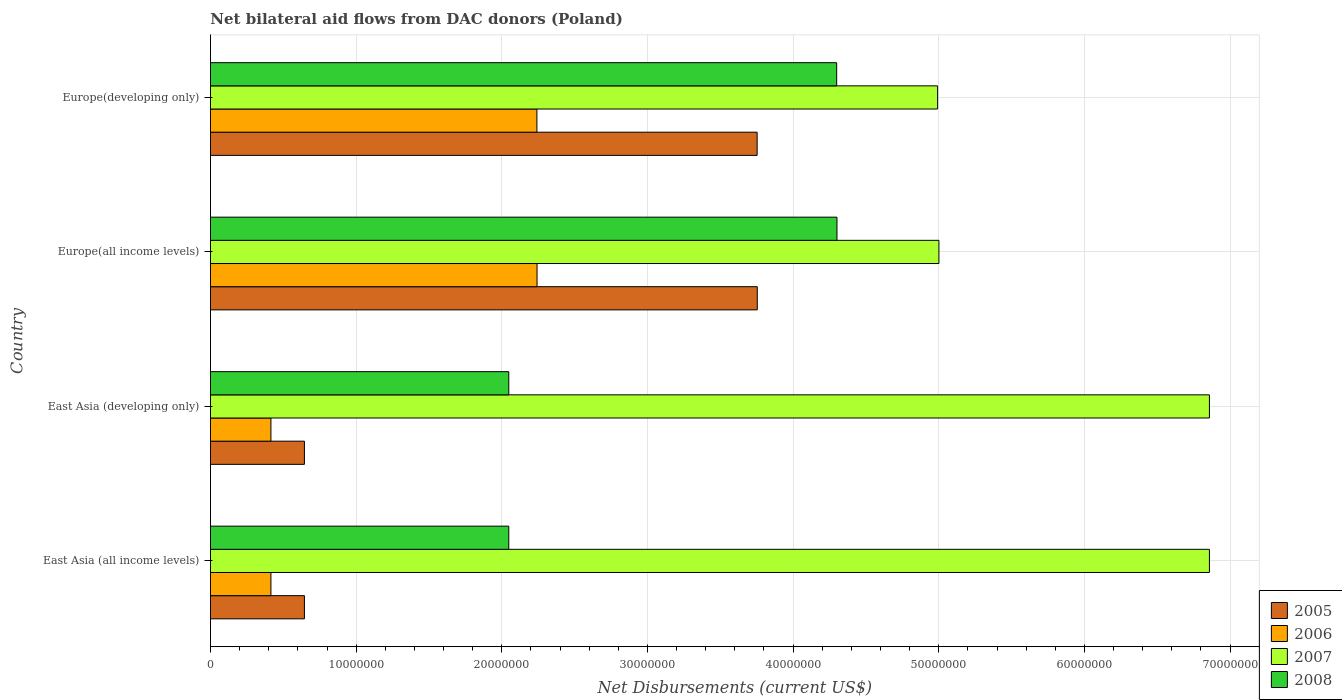Are the number of bars per tick equal to the number of legend labels?
Your answer should be very brief. Yes. How many bars are there on the 4th tick from the top?
Make the answer very short. 4. What is the label of the 2nd group of bars from the top?
Offer a very short reply. Europe(all income levels). In how many cases, is the number of bars for a given country not equal to the number of legend labels?
Ensure brevity in your answer.  0. What is the net bilateral aid flows in 2005 in East Asia (developing only)?
Give a very brief answer. 6.45e+06. Across all countries, what is the maximum net bilateral aid flows in 2007?
Ensure brevity in your answer.  6.86e+07. Across all countries, what is the minimum net bilateral aid flows in 2005?
Give a very brief answer. 6.45e+06. In which country was the net bilateral aid flows in 2006 maximum?
Your answer should be compact. Europe(all income levels). In which country was the net bilateral aid flows in 2006 minimum?
Ensure brevity in your answer.  East Asia (all income levels). What is the total net bilateral aid flows in 2007 in the graph?
Your answer should be compact. 2.37e+08. What is the difference between the net bilateral aid flows in 2008 in East Asia (developing only) and that in Europe(developing only)?
Your answer should be very brief. -2.25e+07. What is the difference between the net bilateral aid flows in 2005 in Europe(developing only) and the net bilateral aid flows in 2006 in Europe(all income levels)?
Make the answer very short. 1.51e+07. What is the average net bilateral aid flows in 2007 per country?
Your response must be concise. 5.93e+07. What is the difference between the net bilateral aid flows in 2006 and net bilateral aid flows in 2008 in East Asia (developing only)?
Provide a short and direct response. -1.63e+07. What is the ratio of the net bilateral aid flows in 2006 in East Asia (all income levels) to that in Europe(developing only)?
Offer a very short reply. 0.19. Is the net bilateral aid flows in 2005 in East Asia (all income levels) less than that in Europe(developing only)?
Offer a terse response. Yes. Is the difference between the net bilateral aid flows in 2006 in East Asia (developing only) and Europe(developing only) greater than the difference between the net bilateral aid flows in 2008 in East Asia (developing only) and Europe(developing only)?
Make the answer very short. Yes. What is the difference between the highest and the lowest net bilateral aid flows in 2005?
Make the answer very short. 3.11e+07. In how many countries, is the net bilateral aid flows in 2006 greater than the average net bilateral aid flows in 2006 taken over all countries?
Make the answer very short. 2. Is the sum of the net bilateral aid flows in 2006 in East Asia (developing only) and Europe(all income levels) greater than the maximum net bilateral aid flows in 2008 across all countries?
Provide a short and direct response. No. Is it the case that in every country, the sum of the net bilateral aid flows in 2008 and net bilateral aid flows in 2005 is greater than the sum of net bilateral aid flows in 2007 and net bilateral aid flows in 2006?
Provide a succinct answer. No. What does the 2nd bar from the top in East Asia (all income levels) represents?
Your answer should be very brief. 2007. What does the 3rd bar from the bottom in East Asia (all income levels) represents?
Your response must be concise. 2007. Is it the case that in every country, the sum of the net bilateral aid flows in 2005 and net bilateral aid flows in 2008 is greater than the net bilateral aid flows in 2006?
Give a very brief answer. Yes. Are all the bars in the graph horizontal?
Ensure brevity in your answer.  Yes. What is the difference between two consecutive major ticks on the X-axis?
Make the answer very short. 1.00e+07. Does the graph contain any zero values?
Offer a very short reply. No. How are the legend labels stacked?
Provide a succinct answer. Vertical. What is the title of the graph?
Your answer should be compact. Net bilateral aid flows from DAC donors (Poland). What is the label or title of the X-axis?
Provide a short and direct response. Net Disbursements (current US$). What is the label or title of the Y-axis?
Provide a short and direct response. Country. What is the Net Disbursements (current US$) of 2005 in East Asia (all income levels)?
Ensure brevity in your answer.  6.45e+06. What is the Net Disbursements (current US$) of 2006 in East Asia (all income levels)?
Your response must be concise. 4.15e+06. What is the Net Disbursements (current US$) of 2007 in East Asia (all income levels)?
Offer a terse response. 6.86e+07. What is the Net Disbursements (current US$) of 2008 in East Asia (all income levels)?
Your answer should be very brief. 2.05e+07. What is the Net Disbursements (current US$) in 2005 in East Asia (developing only)?
Your answer should be very brief. 6.45e+06. What is the Net Disbursements (current US$) in 2006 in East Asia (developing only)?
Your response must be concise. 4.15e+06. What is the Net Disbursements (current US$) of 2007 in East Asia (developing only)?
Offer a terse response. 6.86e+07. What is the Net Disbursements (current US$) in 2008 in East Asia (developing only)?
Provide a succinct answer. 2.05e+07. What is the Net Disbursements (current US$) in 2005 in Europe(all income levels)?
Make the answer very short. 3.75e+07. What is the Net Disbursements (current US$) in 2006 in Europe(all income levels)?
Keep it short and to the point. 2.24e+07. What is the Net Disbursements (current US$) of 2007 in Europe(all income levels)?
Your answer should be very brief. 5.00e+07. What is the Net Disbursements (current US$) of 2008 in Europe(all income levels)?
Make the answer very short. 4.30e+07. What is the Net Disbursements (current US$) of 2005 in Europe(developing only)?
Provide a succinct answer. 3.75e+07. What is the Net Disbursements (current US$) of 2006 in Europe(developing only)?
Make the answer very short. 2.24e+07. What is the Net Disbursements (current US$) of 2007 in Europe(developing only)?
Offer a very short reply. 4.99e+07. What is the Net Disbursements (current US$) of 2008 in Europe(developing only)?
Provide a succinct answer. 4.30e+07. Across all countries, what is the maximum Net Disbursements (current US$) of 2005?
Your answer should be very brief. 3.75e+07. Across all countries, what is the maximum Net Disbursements (current US$) of 2006?
Your answer should be compact. 2.24e+07. Across all countries, what is the maximum Net Disbursements (current US$) of 2007?
Your answer should be very brief. 6.86e+07. Across all countries, what is the maximum Net Disbursements (current US$) of 2008?
Provide a succinct answer. 4.30e+07. Across all countries, what is the minimum Net Disbursements (current US$) of 2005?
Ensure brevity in your answer.  6.45e+06. Across all countries, what is the minimum Net Disbursements (current US$) in 2006?
Provide a succinct answer. 4.15e+06. Across all countries, what is the minimum Net Disbursements (current US$) in 2007?
Ensure brevity in your answer.  4.99e+07. Across all countries, what is the minimum Net Disbursements (current US$) of 2008?
Your answer should be very brief. 2.05e+07. What is the total Net Disbursements (current US$) in 2005 in the graph?
Offer a very short reply. 8.80e+07. What is the total Net Disbursements (current US$) in 2006 in the graph?
Offer a very short reply. 5.31e+07. What is the total Net Disbursements (current US$) in 2007 in the graph?
Provide a short and direct response. 2.37e+08. What is the total Net Disbursements (current US$) in 2008 in the graph?
Provide a succinct answer. 1.27e+08. What is the difference between the Net Disbursements (current US$) in 2008 in East Asia (all income levels) and that in East Asia (developing only)?
Give a very brief answer. 0. What is the difference between the Net Disbursements (current US$) in 2005 in East Asia (all income levels) and that in Europe(all income levels)?
Your answer should be very brief. -3.11e+07. What is the difference between the Net Disbursements (current US$) in 2006 in East Asia (all income levels) and that in Europe(all income levels)?
Make the answer very short. -1.83e+07. What is the difference between the Net Disbursements (current US$) in 2007 in East Asia (all income levels) and that in Europe(all income levels)?
Offer a very short reply. 1.86e+07. What is the difference between the Net Disbursements (current US$) of 2008 in East Asia (all income levels) and that in Europe(all income levels)?
Keep it short and to the point. -2.25e+07. What is the difference between the Net Disbursements (current US$) of 2005 in East Asia (all income levels) and that in Europe(developing only)?
Make the answer very short. -3.11e+07. What is the difference between the Net Disbursements (current US$) in 2006 in East Asia (all income levels) and that in Europe(developing only)?
Offer a terse response. -1.83e+07. What is the difference between the Net Disbursements (current US$) of 2007 in East Asia (all income levels) and that in Europe(developing only)?
Provide a succinct answer. 1.87e+07. What is the difference between the Net Disbursements (current US$) in 2008 in East Asia (all income levels) and that in Europe(developing only)?
Your answer should be compact. -2.25e+07. What is the difference between the Net Disbursements (current US$) in 2005 in East Asia (developing only) and that in Europe(all income levels)?
Provide a short and direct response. -3.11e+07. What is the difference between the Net Disbursements (current US$) in 2006 in East Asia (developing only) and that in Europe(all income levels)?
Ensure brevity in your answer.  -1.83e+07. What is the difference between the Net Disbursements (current US$) of 2007 in East Asia (developing only) and that in Europe(all income levels)?
Offer a terse response. 1.86e+07. What is the difference between the Net Disbursements (current US$) in 2008 in East Asia (developing only) and that in Europe(all income levels)?
Offer a terse response. -2.25e+07. What is the difference between the Net Disbursements (current US$) of 2005 in East Asia (developing only) and that in Europe(developing only)?
Your answer should be compact. -3.11e+07. What is the difference between the Net Disbursements (current US$) of 2006 in East Asia (developing only) and that in Europe(developing only)?
Provide a succinct answer. -1.83e+07. What is the difference between the Net Disbursements (current US$) of 2007 in East Asia (developing only) and that in Europe(developing only)?
Provide a succinct answer. 1.87e+07. What is the difference between the Net Disbursements (current US$) of 2008 in East Asia (developing only) and that in Europe(developing only)?
Offer a very short reply. -2.25e+07. What is the difference between the Net Disbursements (current US$) in 2008 in Europe(all income levels) and that in Europe(developing only)?
Provide a short and direct response. 2.00e+04. What is the difference between the Net Disbursements (current US$) of 2005 in East Asia (all income levels) and the Net Disbursements (current US$) of 2006 in East Asia (developing only)?
Give a very brief answer. 2.30e+06. What is the difference between the Net Disbursements (current US$) of 2005 in East Asia (all income levels) and the Net Disbursements (current US$) of 2007 in East Asia (developing only)?
Provide a succinct answer. -6.21e+07. What is the difference between the Net Disbursements (current US$) in 2005 in East Asia (all income levels) and the Net Disbursements (current US$) in 2008 in East Asia (developing only)?
Offer a terse response. -1.40e+07. What is the difference between the Net Disbursements (current US$) in 2006 in East Asia (all income levels) and the Net Disbursements (current US$) in 2007 in East Asia (developing only)?
Provide a short and direct response. -6.44e+07. What is the difference between the Net Disbursements (current US$) of 2006 in East Asia (all income levels) and the Net Disbursements (current US$) of 2008 in East Asia (developing only)?
Offer a terse response. -1.63e+07. What is the difference between the Net Disbursements (current US$) of 2007 in East Asia (all income levels) and the Net Disbursements (current US$) of 2008 in East Asia (developing only)?
Your response must be concise. 4.81e+07. What is the difference between the Net Disbursements (current US$) of 2005 in East Asia (all income levels) and the Net Disbursements (current US$) of 2006 in Europe(all income levels)?
Offer a very short reply. -1.60e+07. What is the difference between the Net Disbursements (current US$) in 2005 in East Asia (all income levels) and the Net Disbursements (current US$) in 2007 in Europe(all income levels)?
Your response must be concise. -4.36e+07. What is the difference between the Net Disbursements (current US$) of 2005 in East Asia (all income levels) and the Net Disbursements (current US$) of 2008 in Europe(all income levels)?
Give a very brief answer. -3.66e+07. What is the difference between the Net Disbursements (current US$) in 2006 in East Asia (all income levels) and the Net Disbursements (current US$) in 2007 in Europe(all income levels)?
Keep it short and to the point. -4.59e+07. What is the difference between the Net Disbursements (current US$) in 2006 in East Asia (all income levels) and the Net Disbursements (current US$) in 2008 in Europe(all income levels)?
Your response must be concise. -3.89e+07. What is the difference between the Net Disbursements (current US$) of 2007 in East Asia (all income levels) and the Net Disbursements (current US$) of 2008 in Europe(all income levels)?
Keep it short and to the point. 2.56e+07. What is the difference between the Net Disbursements (current US$) in 2005 in East Asia (all income levels) and the Net Disbursements (current US$) in 2006 in Europe(developing only)?
Your answer should be very brief. -1.60e+07. What is the difference between the Net Disbursements (current US$) in 2005 in East Asia (all income levels) and the Net Disbursements (current US$) in 2007 in Europe(developing only)?
Your response must be concise. -4.35e+07. What is the difference between the Net Disbursements (current US$) in 2005 in East Asia (all income levels) and the Net Disbursements (current US$) in 2008 in Europe(developing only)?
Your answer should be very brief. -3.65e+07. What is the difference between the Net Disbursements (current US$) of 2006 in East Asia (all income levels) and the Net Disbursements (current US$) of 2007 in Europe(developing only)?
Your answer should be very brief. -4.58e+07. What is the difference between the Net Disbursements (current US$) in 2006 in East Asia (all income levels) and the Net Disbursements (current US$) in 2008 in Europe(developing only)?
Offer a terse response. -3.88e+07. What is the difference between the Net Disbursements (current US$) of 2007 in East Asia (all income levels) and the Net Disbursements (current US$) of 2008 in Europe(developing only)?
Offer a very short reply. 2.56e+07. What is the difference between the Net Disbursements (current US$) of 2005 in East Asia (developing only) and the Net Disbursements (current US$) of 2006 in Europe(all income levels)?
Provide a short and direct response. -1.60e+07. What is the difference between the Net Disbursements (current US$) in 2005 in East Asia (developing only) and the Net Disbursements (current US$) in 2007 in Europe(all income levels)?
Give a very brief answer. -4.36e+07. What is the difference between the Net Disbursements (current US$) of 2005 in East Asia (developing only) and the Net Disbursements (current US$) of 2008 in Europe(all income levels)?
Your answer should be very brief. -3.66e+07. What is the difference between the Net Disbursements (current US$) of 2006 in East Asia (developing only) and the Net Disbursements (current US$) of 2007 in Europe(all income levels)?
Offer a very short reply. -4.59e+07. What is the difference between the Net Disbursements (current US$) in 2006 in East Asia (developing only) and the Net Disbursements (current US$) in 2008 in Europe(all income levels)?
Provide a short and direct response. -3.89e+07. What is the difference between the Net Disbursements (current US$) of 2007 in East Asia (developing only) and the Net Disbursements (current US$) of 2008 in Europe(all income levels)?
Make the answer very short. 2.56e+07. What is the difference between the Net Disbursements (current US$) of 2005 in East Asia (developing only) and the Net Disbursements (current US$) of 2006 in Europe(developing only)?
Offer a very short reply. -1.60e+07. What is the difference between the Net Disbursements (current US$) in 2005 in East Asia (developing only) and the Net Disbursements (current US$) in 2007 in Europe(developing only)?
Offer a very short reply. -4.35e+07. What is the difference between the Net Disbursements (current US$) in 2005 in East Asia (developing only) and the Net Disbursements (current US$) in 2008 in Europe(developing only)?
Offer a terse response. -3.65e+07. What is the difference between the Net Disbursements (current US$) in 2006 in East Asia (developing only) and the Net Disbursements (current US$) in 2007 in Europe(developing only)?
Your answer should be compact. -4.58e+07. What is the difference between the Net Disbursements (current US$) of 2006 in East Asia (developing only) and the Net Disbursements (current US$) of 2008 in Europe(developing only)?
Provide a succinct answer. -3.88e+07. What is the difference between the Net Disbursements (current US$) of 2007 in East Asia (developing only) and the Net Disbursements (current US$) of 2008 in Europe(developing only)?
Provide a short and direct response. 2.56e+07. What is the difference between the Net Disbursements (current US$) of 2005 in Europe(all income levels) and the Net Disbursements (current US$) of 2006 in Europe(developing only)?
Offer a terse response. 1.51e+07. What is the difference between the Net Disbursements (current US$) in 2005 in Europe(all income levels) and the Net Disbursements (current US$) in 2007 in Europe(developing only)?
Provide a succinct answer. -1.24e+07. What is the difference between the Net Disbursements (current US$) of 2005 in Europe(all income levels) and the Net Disbursements (current US$) of 2008 in Europe(developing only)?
Give a very brief answer. -5.45e+06. What is the difference between the Net Disbursements (current US$) in 2006 in Europe(all income levels) and the Net Disbursements (current US$) in 2007 in Europe(developing only)?
Provide a succinct answer. -2.75e+07. What is the difference between the Net Disbursements (current US$) of 2006 in Europe(all income levels) and the Net Disbursements (current US$) of 2008 in Europe(developing only)?
Make the answer very short. -2.06e+07. What is the difference between the Net Disbursements (current US$) in 2007 in Europe(all income levels) and the Net Disbursements (current US$) in 2008 in Europe(developing only)?
Ensure brevity in your answer.  7.02e+06. What is the average Net Disbursements (current US$) of 2005 per country?
Make the answer very short. 2.20e+07. What is the average Net Disbursements (current US$) in 2006 per country?
Provide a succinct answer. 1.33e+07. What is the average Net Disbursements (current US$) in 2007 per country?
Make the answer very short. 5.93e+07. What is the average Net Disbursements (current US$) in 2008 per country?
Offer a very short reply. 3.17e+07. What is the difference between the Net Disbursements (current US$) in 2005 and Net Disbursements (current US$) in 2006 in East Asia (all income levels)?
Your answer should be very brief. 2.30e+06. What is the difference between the Net Disbursements (current US$) in 2005 and Net Disbursements (current US$) in 2007 in East Asia (all income levels)?
Your response must be concise. -6.21e+07. What is the difference between the Net Disbursements (current US$) in 2005 and Net Disbursements (current US$) in 2008 in East Asia (all income levels)?
Offer a very short reply. -1.40e+07. What is the difference between the Net Disbursements (current US$) in 2006 and Net Disbursements (current US$) in 2007 in East Asia (all income levels)?
Ensure brevity in your answer.  -6.44e+07. What is the difference between the Net Disbursements (current US$) in 2006 and Net Disbursements (current US$) in 2008 in East Asia (all income levels)?
Provide a short and direct response. -1.63e+07. What is the difference between the Net Disbursements (current US$) of 2007 and Net Disbursements (current US$) of 2008 in East Asia (all income levels)?
Offer a terse response. 4.81e+07. What is the difference between the Net Disbursements (current US$) in 2005 and Net Disbursements (current US$) in 2006 in East Asia (developing only)?
Keep it short and to the point. 2.30e+06. What is the difference between the Net Disbursements (current US$) in 2005 and Net Disbursements (current US$) in 2007 in East Asia (developing only)?
Offer a very short reply. -6.21e+07. What is the difference between the Net Disbursements (current US$) of 2005 and Net Disbursements (current US$) of 2008 in East Asia (developing only)?
Make the answer very short. -1.40e+07. What is the difference between the Net Disbursements (current US$) in 2006 and Net Disbursements (current US$) in 2007 in East Asia (developing only)?
Provide a succinct answer. -6.44e+07. What is the difference between the Net Disbursements (current US$) of 2006 and Net Disbursements (current US$) of 2008 in East Asia (developing only)?
Offer a very short reply. -1.63e+07. What is the difference between the Net Disbursements (current US$) in 2007 and Net Disbursements (current US$) in 2008 in East Asia (developing only)?
Your answer should be compact. 4.81e+07. What is the difference between the Net Disbursements (current US$) of 2005 and Net Disbursements (current US$) of 2006 in Europe(all income levels)?
Your answer should be compact. 1.51e+07. What is the difference between the Net Disbursements (current US$) in 2005 and Net Disbursements (current US$) in 2007 in Europe(all income levels)?
Offer a very short reply. -1.25e+07. What is the difference between the Net Disbursements (current US$) of 2005 and Net Disbursements (current US$) of 2008 in Europe(all income levels)?
Offer a very short reply. -5.47e+06. What is the difference between the Net Disbursements (current US$) of 2006 and Net Disbursements (current US$) of 2007 in Europe(all income levels)?
Provide a succinct answer. -2.76e+07. What is the difference between the Net Disbursements (current US$) of 2006 and Net Disbursements (current US$) of 2008 in Europe(all income levels)?
Provide a short and direct response. -2.06e+07. What is the difference between the Net Disbursements (current US$) in 2007 and Net Disbursements (current US$) in 2008 in Europe(all income levels)?
Provide a succinct answer. 7.00e+06. What is the difference between the Net Disbursements (current US$) of 2005 and Net Disbursements (current US$) of 2006 in Europe(developing only)?
Provide a short and direct response. 1.51e+07. What is the difference between the Net Disbursements (current US$) of 2005 and Net Disbursements (current US$) of 2007 in Europe(developing only)?
Make the answer very short. -1.24e+07. What is the difference between the Net Disbursements (current US$) in 2005 and Net Disbursements (current US$) in 2008 in Europe(developing only)?
Make the answer very short. -5.46e+06. What is the difference between the Net Disbursements (current US$) of 2006 and Net Disbursements (current US$) of 2007 in Europe(developing only)?
Your answer should be compact. -2.75e+07. What is the difference between the Net Disbursements (current US$) in 2006 and Net Disbursements (current US$) in 2008 in Europe(developing only)?
Your response must be concise. -2.06e+07. What is the difference between the Net Disbursements (current US$) of 2007 and Net Disbursements (current US$) of 2008 in Europe(developing only)?
Provide a succinct answer. 6.93e+06. What is the ratio of the Net Disbursements (current US$) of 2005 in East Asia (all income levels) to that in East Asia (developing only)?
Offer a very short reply. 1. What is the ratio of the Net Disbursements (current US$) of 2005 in East Asia (all income levels) to that in Europe(all income levels)?
Give a very brief answer. 0.17. What is the ratio of the Net Disbursements (current US$) of 2006 in East Asia (all income levels) to that in Europe(all income levels)?
Provide a succinct answer. 0.19. What is the ratio of the Net Disbursements (current US$) in 2007 in East Asia (all income levels) to that in Europe(all income levels)?
Give a very brief answer. 1.37. What is the ratio of the Net Disbursements (current US$) of 2008 in East Asia (all income levels) to that in Europe(all income levels)?
Offer a very short reply. 0.48. What is the ratio of the Net Disbursements (current US$) of 2005 in East Asia (all income levels) to that in Europe(developing only)?
Give a very brief answer. 0.17. What is the ratio of the Net Disbursements (current US$) in 2006 in East Asia (all income levels) to that in Europe(developing only)?
Offer a terse response. 0.19. What is the ratio of the Net Disbursements (current US$) in 2007 in East Asia (all income levels) to that in Europe(developing only)?
Offer a very short reply. 1.37. What is the ratio of the Net Disbursements (current US$) of 2008 in East Asia (all income levels) to that in Europe(developing only)?
Give a very brief answer. 0.48. What is the ratio of the Net Disbursements (current US$) in 2005 in East Asia (developing only) to that in Europe(all income levels)?
Offer a very short reply. 0.17. What is the ratio of the Net Disbursements (current US$) of 2006 in East Asia (developing only) to that in Europe(all income levels)?
Make the answer very short. 0.19. What is the ratio of the Net Disbursements (current US$) of 2007 in East Asia (developing only) to that in Europe(all income levels)?
Offer a terse response. 1.37. What is the ratio of the Net Disbursements (current US$) of 2008 in East Asia (developing only) to that in Europe(all income levels)?
Your answer should be very brief. 0.48. What is the ratio of the Net Disbursements (current US$) of 2005 in East Asia (developing only) to that in Europe(developing only)?
Provide a short and direct response. 0.17. What is the ratio of the Net Disbursements (current US$) in 2006 in East Asia (developing only) to that in Europe(developing only)?
Give a very brief answer. 0.19. What is the ratio of the Net Disbursements (current US$) in 2007 in East Asia (developing only) to that in Europe(developing only)?
Ensure brevity in your answer.  1.37. What is the ratio of the Net Disbursements (current US$) of 2008 in East Asia (developing only) to that in Europe(developing only)?
Offer a very short reply. 0.48. What is the ratio of the Net Disbursements (current US$) in 2005 in Europe(all income levels) to that in Europe(developing only)?
Your answer should be compact. 1. What is the ratio of the Net Disbursements (current US$) of 2006 in Europe(all income levels) to that in Europe(developing only)?
Your response must be concise. 1. What is the difference between the highest and the second highest Net Disbursements (current US$) of 2005?
Ensure brevity in your answer.  10000. What is the difference between the highest and the second highest Net Disbursements (current US$) in 2006?
Give a very brief answer. 10000. What is the difference between the highest and the lowest Net Disbursements (current US$) of 2005?
Ensure brevity in your answer.  3.11e+07. What is the difference between the highest and the lowest Net Disbursements (current US$) in 2006?
Your response must be concise. 1.83e+07. What is the difference between the highest and the lowest Net Disbursements (current US$) in 2007?
Keep it short and to the point. 1.87e+07. What is the difference between the highest and the lowest Net Disbursements (current US$) of 2008?
Make the answer very short. 2.25e+07. 